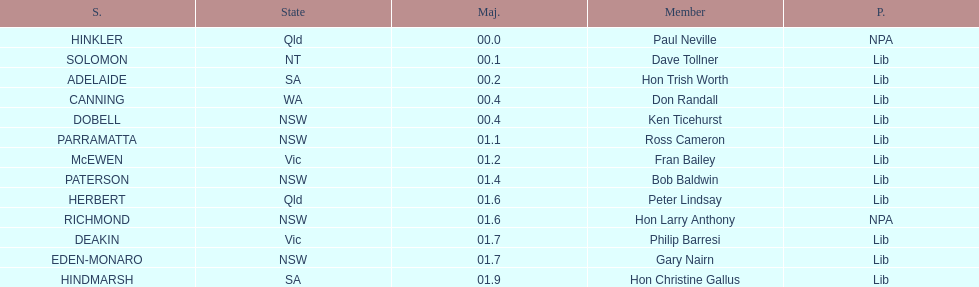Could you parse the entire table? {'header': ['S.', 'State', 'Maj.', 'Member', 'P.'], 'rows': [['HINKLER', 'Qld', '00.0', 'Paul Neville', 'NPA'], ['SOLOMON', 'NT', '00.1', 'Dave Tollner', 'Lib'], ['ADELAIDE', 'SA', '00.2', 'Hon Trish Worth', 'Lib'], ['CANNING', 'WA', '00.4', 'Don Randall', 'Lib'], ['DOBELL', 'NSW', '00.4', 'Ken Ticehurst', 'Lib'], ['PARRAMATTA', 'NSW', '01.1', 'Ross Cameron', 'Lib'], ['McEWEN', 'Vic', '01.2', 'Fran Bailey', 'Lib'], ['PATERSON', 'NSW', '01.4', 'Bob Baldwin', 'Lib'], ['HERBERT', 'Qld', '01.6', 'Peter Lindsay', 'Lib'], ['RICHMOND', 'NSW', '01.6', 'Hon Larry Anthony', 'NPA'], ['DEAKIN', 'Vic', '01.7', 'Philip Barresi', 'Lib'], ['EDEN-MONARO', 'NSW', '01.7', 'Gary Nairn', 'Lib'], ['HINDMARSH', 'SA', '01.9', 'Hon Christine Gallus', 'Lib']]} What is the difference in majority between hindmarsh and hinkler? 01.9. 